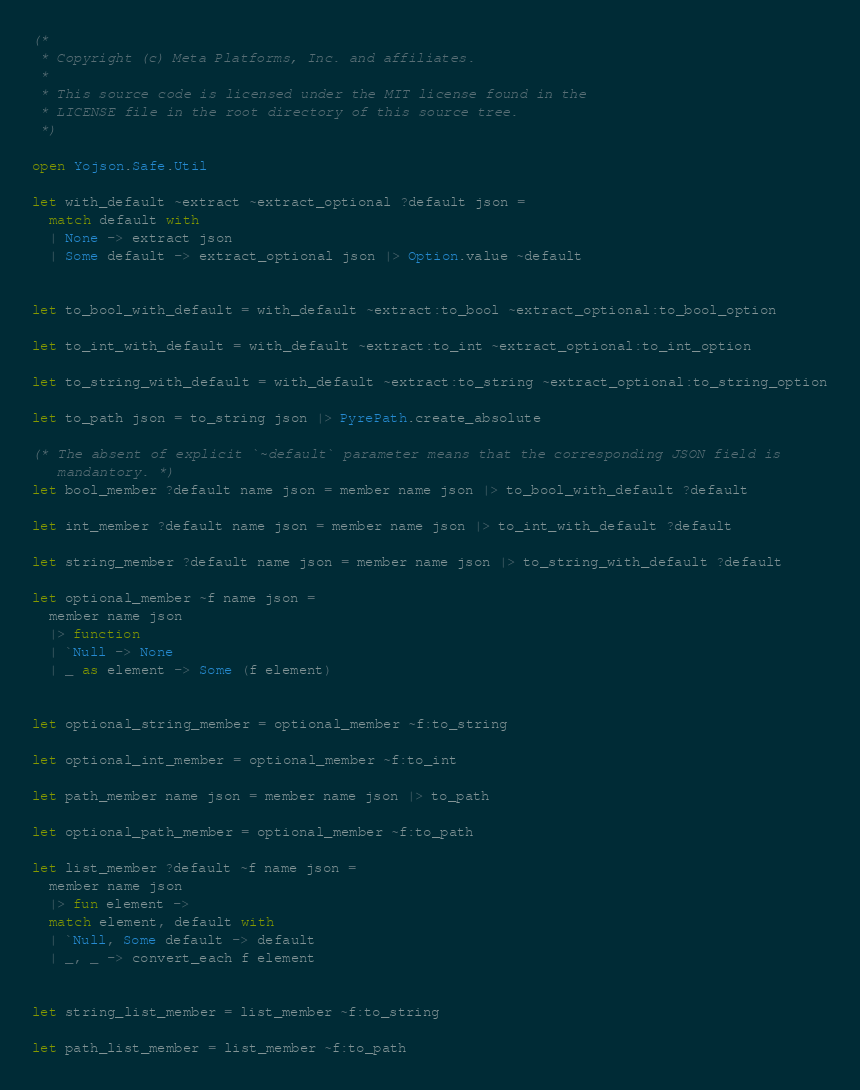<code> <loc_0><loc_0><loc_500><loc_500><_OCaml_>(*
 * Copyright (c) Meta Platforms, Inc. and affiliates.
 *
 * This source code is licensed under the MIT license found in the
 * LICENSE file in the root directory of this source tree.
 *)

open Yojson.Safe.Util

let with_default ~extract ~extract_optional ?default json =
  match default with
  | None -> extract json
  | Some default -> extract_optional json |> Option.value ~default


let to_bool_with_default = with_default ~extract:to_bool ~extract_optional:to_bool_option

let to_int_with_default = with_default ~extract:to_int ~extract_optional:to_int_option

let to_string_with_default = with_default ~extract:to_string ~extract_optional:to_string_option

let to_path json = to_string json |> PyrePath.create_absolute

(* The absent of explicit `~default` parameter means that the corresponding JSON field is
   mandantory. *)
let bool_member ?default name json = member name json |> to_bool_with_default ?default

let int_member ?default name json = member name json |> to_int_with_default ?default

let string_member ?default name json = member name json |> to_string_with_default ?default

let optional_member ~f name json =
  member name json
  |> function
  | `Null -> None
  | _ as element -> Some (f element)


let optional_string_member = optional_member ~f:to_string

let optional_int_member = optional_member ~f:to_int

let path_member name json = member name json |> to_path

let optional_path_member = optional_member ~f:to_path

let list_member ?default ~f name json =
  member name json
  |> fun element ->
  match element, default with
  | `Null, Some default -> default
  | _, _ -> convert_each f element


let string_list_member = list_member ~f:to_string

let path_list_member = list_member ~f:to_path
</code> 